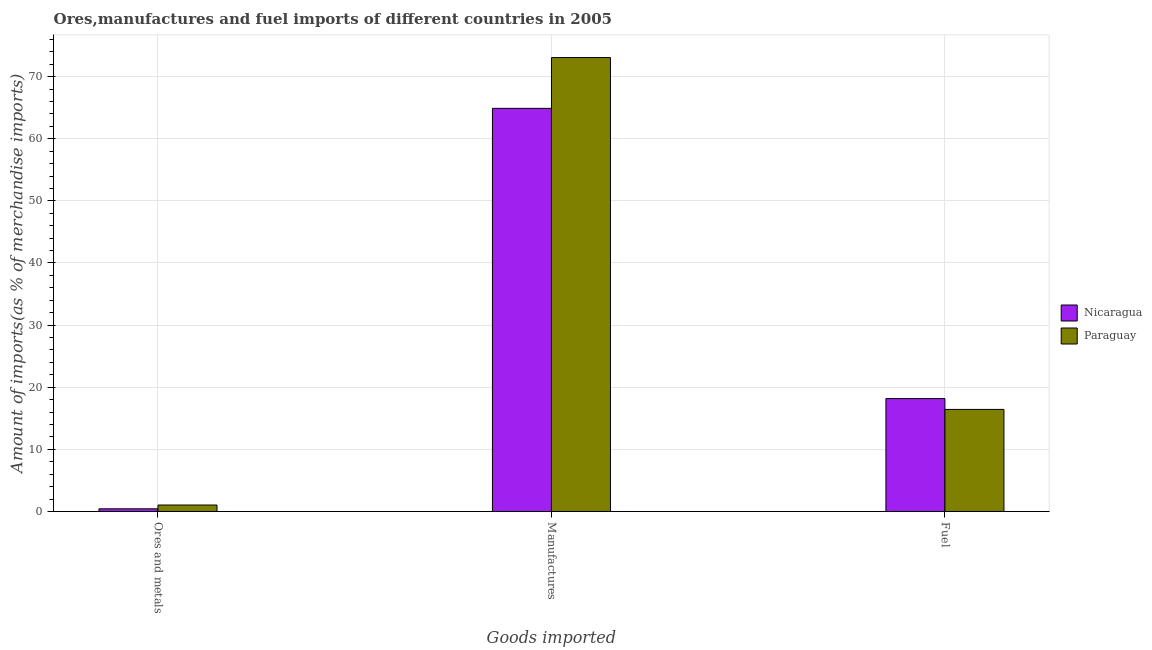How many groups of bars are there?
Provide a succinct answer. 3. What is the label of the 1st group of bars from the left?
Offer a very short reply. Ores and metals. What is the percentage of fuel imports in Nicaragua?
Offer a very short reply. 18.17. Across all countries, what is the maximum percentage of fuel imports?
Your response must be concise. 18.17. Across all countries, what is the minimum percentage of ores and metals imports?
Your answer should be very brief. 0.43. In which country was the percentage of fuel imports maximum?
Offer a terse response. Nicaragua. In which country was the percentage of fuel imports minimum?
Provide a short and direct response. Paraguay. What is the total percentage of fuel imports in the graph?
Give a very brief answer. 34.6. What is the difference between the percentage of ores and metals imports in Paraguay and that in Nicaragua?
Your answer should be very brief. 0.61. What is the difference between the percentage of ores and metals imports in Nicaragua and the percentage of manufactures imports in Paraguay?
Your answer should be compact. -72.64. What is the average percentage of ores and metals imports per country?
Offer a very short reply. 0.74. What is the difference between the percentage of manufactures imports and percentage of fuel imports in Paraguay?
Offer a very short reply. 56.64. What is the ratio of the percentage of fuel imports in Nicaragua to that in Paraguay?
Offer a very short reply. 1.11. What is the difference between the highest and the second highest percentage of ores and metals imports?
Make the answer very short. 0.61. What is the difference between the highest and the lowest percentage of fuel imports?
Give a very brief answer. 1.74. In how many countries, is the percentage of ores and metals imports greater than the average percentage of ores and metals imports taken over all countries?
Your answer should be compact. 1. Is the sum of the percentage of ores and metals imports in Nicaragua and Paraguay greater than the maximum percentage of fuel imports across all countries?
Your response must be concise. No. What does the 2nd bar from the left in Ores and metals represents?
Offer a terse response. Paraguay. What does the 1st bar from the right in Fuel represents?
Give a very brief answer. Paraguay. How many bars are there?
Give a very brief answer. 6. Are all the bars in the graph horizontal?
Your answer should be compact. No. What is the difference between two consecutive major ticks on the Y-axis?
Your response must be concise. 10. Does the graph contain any zero values?
Provide a short and direct response. No. Does the graph contain grids?
Give a very brief answer. Yes. How are the legend labels stacked?
Your answer should be very brief. Vertical. What is the title of the graph?
Your response must be concise. Ores,manufactures and fuel imports of different countries in 2005. What is the label or title of the X-axis?
Offer a terse response. Goods imported. What is the label or title of the Y-axis?
Your answer should be compact. Amount of imports(as % of merchandise imports). What is the Amount of imports(as % of merchandise imports) of Nicaragua in Ores and metals?
Offer a very short reply. 0.43. What is the Amount of imports(as % of merchandise imports) of Paraguay in Ores and metals?
Your response must be concise. 1.04. What is the Amount of imports(as % of merchandise imports) in Nicaragua in Manufactures?
Provide a succinct answer. 64.89. What is the Amount of imports(as % of merchandise imports) in Paraguay in Manufactures?
Give a very brief answer. 73.07. What is the Amount of imports(as % of merchandise imports) in Nicaragua in Fuel?
Provide a short and direct response. 18.17. What is the Amount of imports(as % of merchandise imports) of Paraguay in Fuel?
Offer a very short reply. 16.43. Across all Goods imported, what is the maximum Amount of imports(as % of merchandise imports) of Nicaragua?
Keep it short and to the point. 64.89. Across all Goods imported, what is the maximum Amount of imports(as % of merchandise imports) of Paraguay?
Provide a short and direct response. 73.07. Across all Goods imported, what is the minimum Amount of imports(as % of merchandise imports) in Nicaragua?
Provide a succinct answer. 0.43. Across all Goods imported, what is the minimum Amount of imports(as % of merchandise imports) in Paraguay?
Your response must be concise. 1.04. What is the total Amount of imports(as % of merchandise imports) of Nicaragua in the graph?
Keep it short and to the point. 83.5. What is the total Amount of imports(as % of merchandise imports) of Paraguay in the graph?
Your response must be concise. 90.54. What is the difference between the Amount of imports(as % of merchandise imports) of Nicaragua in Ores and metals and that in Manufactures?
Provide a succinct answer. -64.46. What is the difference between the Amount of imports(as % of merchandise imports) in Paraguay in Ores and metals and that in Manufactures?
Keep it short and to the point. -72.03. What is the difference between the Amount of imports(as % of merchandise imports) of Nicaragua in Ores and metals and that in Fuel?
Make the answer very short. -17.74. What is the difference between the Amount of imports(as % of merchandise imports) in Paraguay in Ores and metals and that in Fuel?
Offer a terse response. -15.39. What is the difference between the Amount of imports(as % of merchandise imports) of Nicaragua in Manufactures and that in Fuel?
Your answer should be compact. 46.72. What is the difference between the Amount of imports(as % of merchandise imports) in Paraguay in Manufactures and that in Fuel?
Ensure brevity in your answer.  56.64. What is the difference between the Amount of imports(as % of merchandise imports) in Nicaragua in Ores and metals and the Amount of imports(as % of merchandise imports) in Paraguay in Manufactures?
Your answer should be very brief. -72.64. What is the difference between the Amount of imports(as % of merchandise imports) in Nicaragua in Ores and metals and the Amount of imports(as % of merchandise imports) in Paraguay in Fuel?
Make the answer very short. -16. What is the difference between the Amount of imports(as % of merchandise imports) in Nicaragua in Manufactures and the Amount of imports(as % of merchandise imports) in Paraguay in Fuel?
Make the answer very short. 48.46. What is the average Amount of imports(as % of merchandise imports) in Nicaragua per Goods imported?
Offer a very short reply. 27.83. What is the average Amount of imports(as % of merchandise imports) of Paraguay per Goods imported?
Provide a succinct answer. 30.18. What is the difference between the Amount of imports(as % of merchandise imports) of Nicaragua and Amount of imports(as % of merchandise imports) of Paraguay in Ores and metals?
Offer a terse response. -0.61. What is the difference between the Amount of imports(as % of merchandise imports) of Nicaragua and Amount of imports(as % of merchandise imports) of Paraguay in Manufactures?
Keep it short and to the point. -8.17. What is the difference between the Amount of imports(as % of merchandise imports) in Nicaragua and Amount of imports(as % of merchandise imports) in Paraguay in Fuel?
Keep it short and to the point. 1.74. What is the ratio of the Amount of imports(as % of merchandise imports) of Nicaragua in Ores and metals to that in Manufactures?
Your response must be concise. 0.01. What is the ratio of the Amount of imports(as % of merchandise imports) in Paraguay in Ores and metals to that in Manufactures?
Make the answer very short. 0.01. What is the ratio of the Amount of imports(as % of merchandise imports) of Nicaragua in Ores and metals to that in Fuel?
Provide a short and direct response. 0.02. What is the ratio of the Amount of imports(as % of merchandise imports) of Paraguay in Ores and metals to that in Fuel?
Your response must be concise. 0.06. What is the ratio of the Amount of imports(as % of merchandise imports) in Nicaragua in Manufactures to that in Fuel?
Offer a very short reply. 3.57. What is the ratio of the Amount of imports(as % of merchandise imports) of Paraguay in Manufactures to that in Fuel?
Provide a short and direct response. 4.45. What is the difference between the highest and the second highest Amount of imports(as % of merchandise imports) of Nicaragua?
Ensure brevity in your answer.  46.72. What is the difference between the highest and the second highest Amount of imports(as % of merchandise imports) in Paraguay?
Your answer should be very brief. 56.64. What is the difference between the highest and the lowest Amount of imports(as % of merchandise imports) in Nicaragua?
Provide a succinct answer. 64.46. What is the difference between the highest and the lowest Amount of imports(as % of merchandise imports) in Paraguay?
Provide a short and direct response. 72.03. 